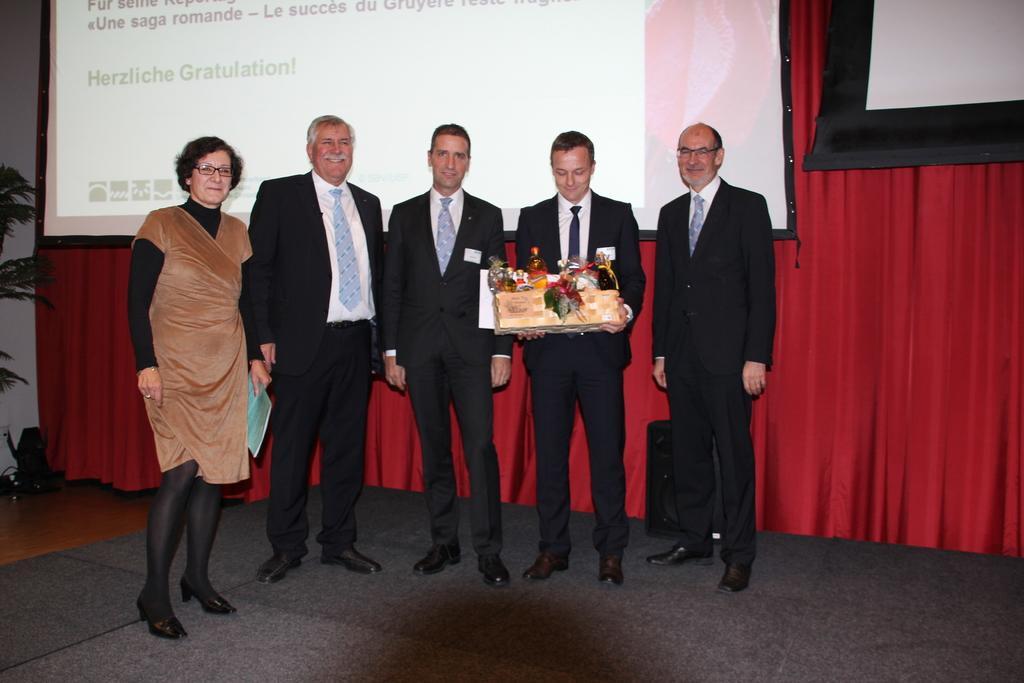Could you give a brief overview of what you see in this image? In the image there are few people standing and there is a man holding the packet in his hand. Behind them there is a red color curtain with screens on it. On the left side of the image there is a plant with leaves. They are standing on the black surface. 